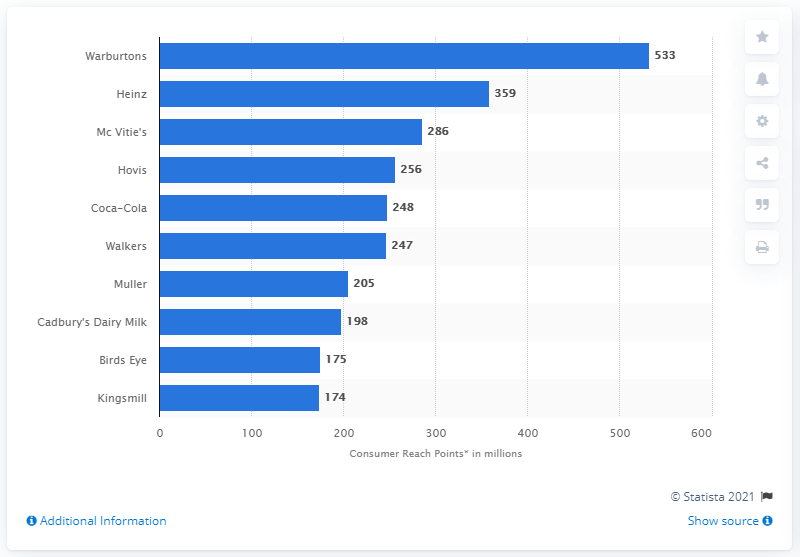List a handful of essential elements in this visual. Warburtons had 533 consumer reach points in 2019. In 2019, Warburtons had a total of 533 consumer reach points. According to Warburtons' data, their second highest consumer reach point was Heinz. 